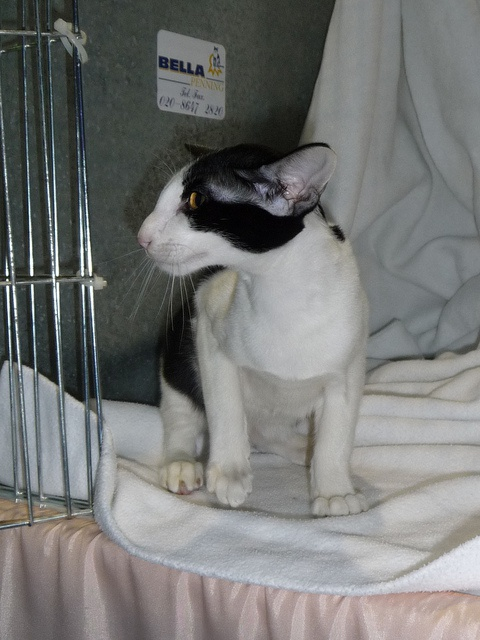Describe the objects in this image and their specific colors. I can see bed in black, darkgray, gray, and lightgray tones and cat in black, darkgray, and gray tones in this image. 